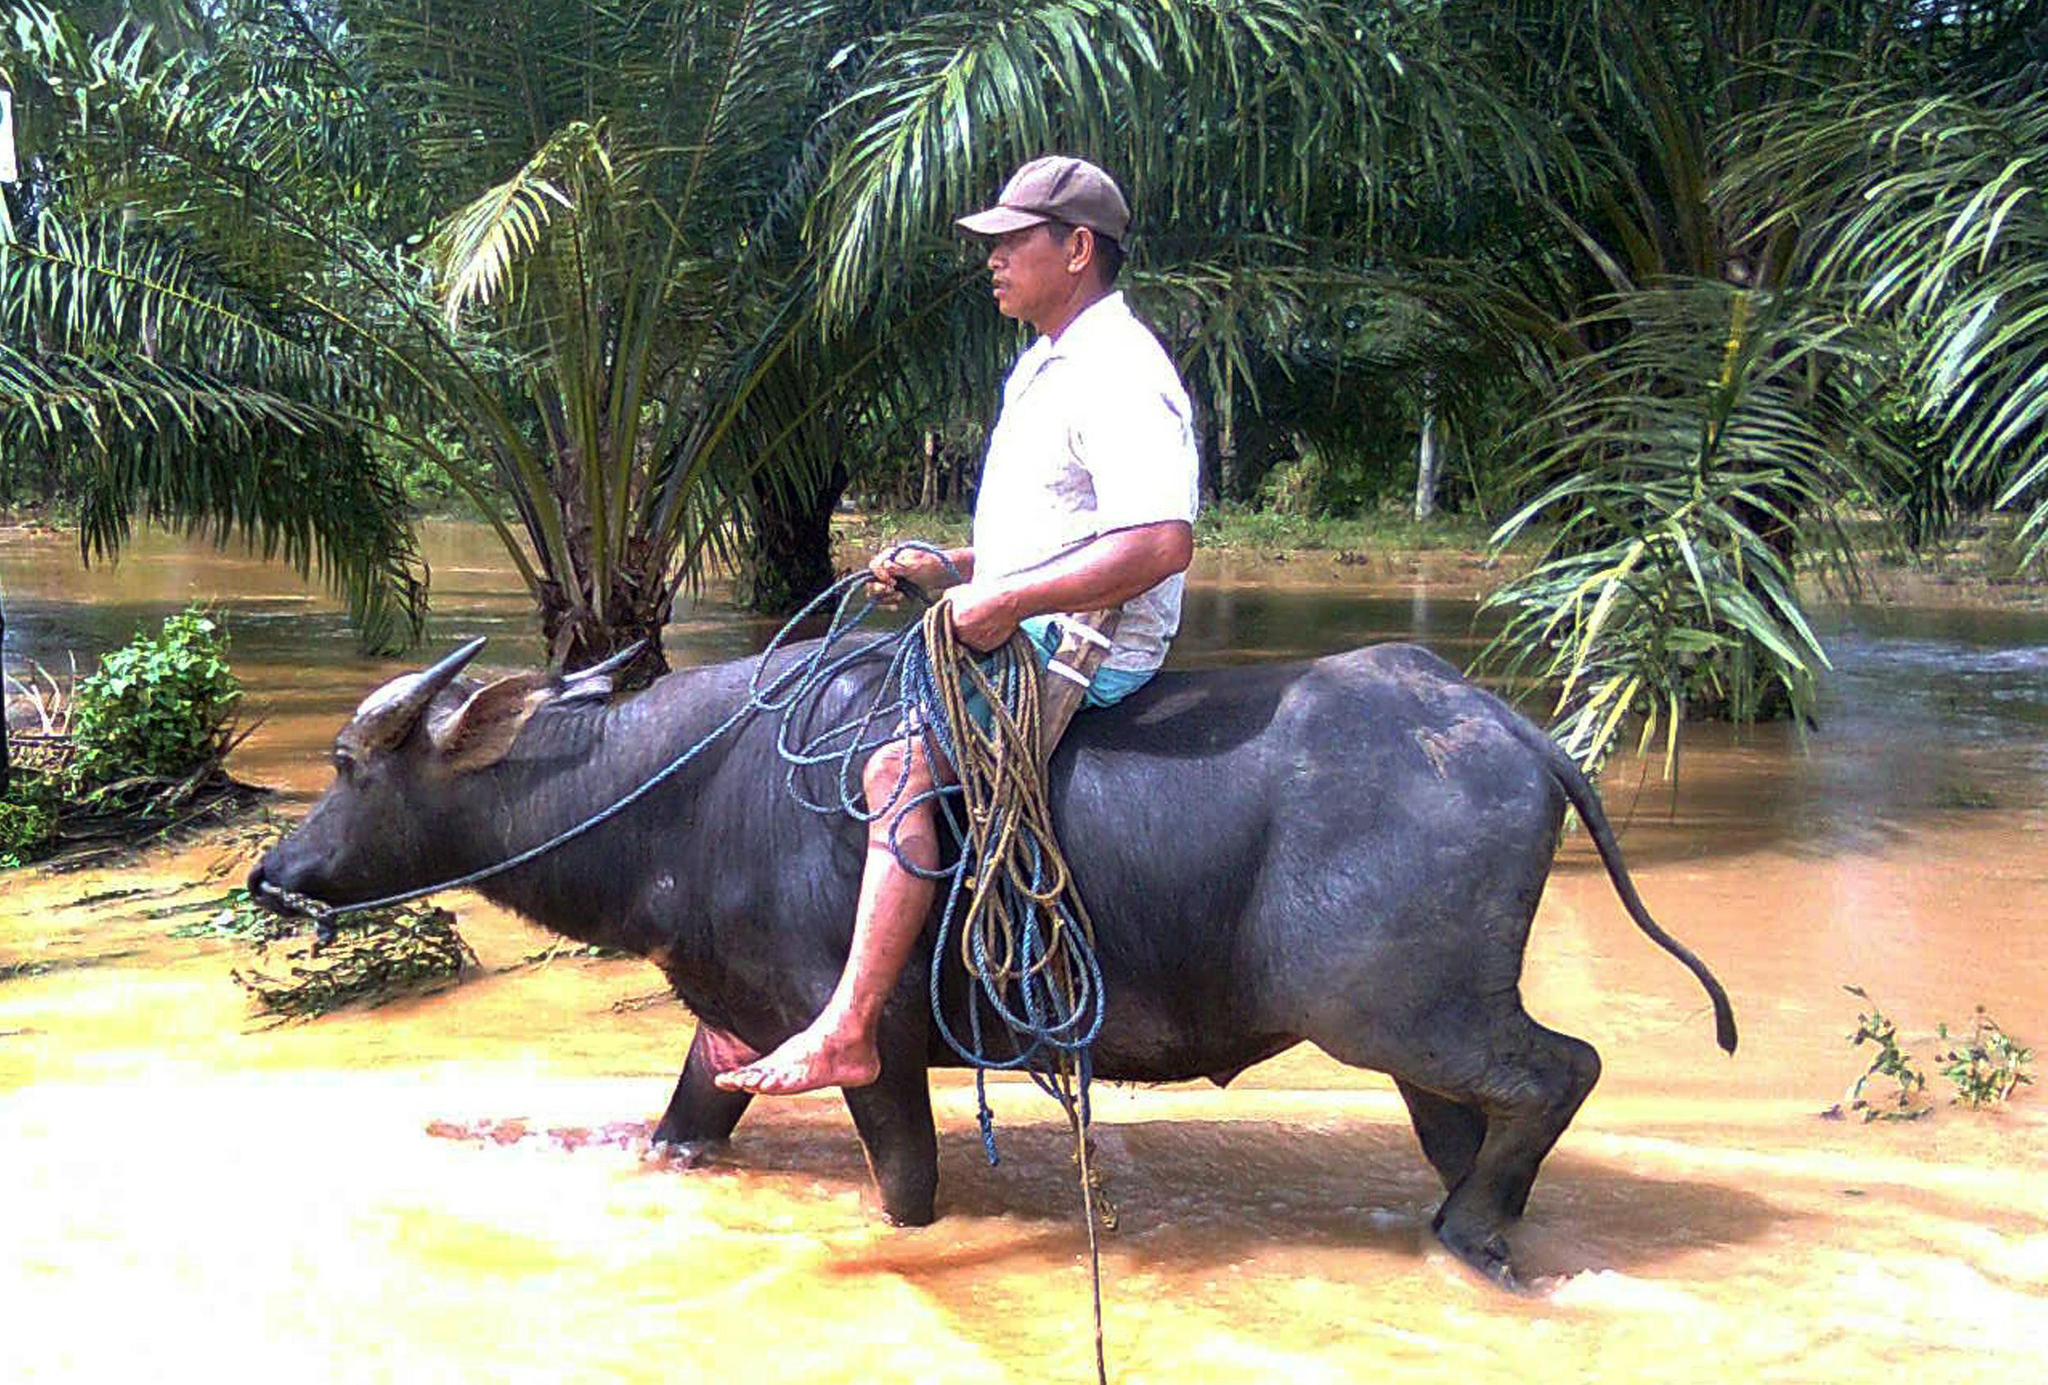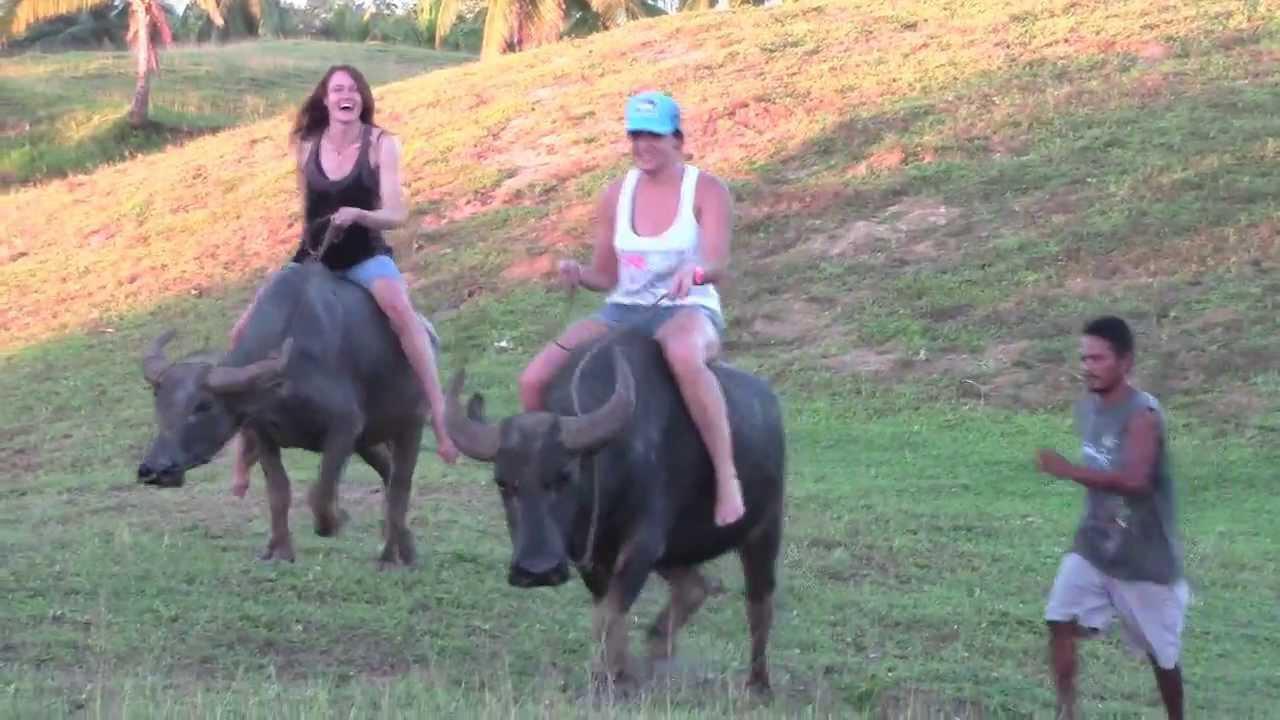The first image is the image on the left, the second image is the image on the right. Analyze the images presented: Is the assertion "At least one water buffalo is standing in water in the left image." valid? Answer yes or no. Yes. The first image is the image on the left, the second image is the image on the right. For the images shown, is this caption "The right image contains at least two people riding on a water buffalo." true? Answer yes or no. Yes. 